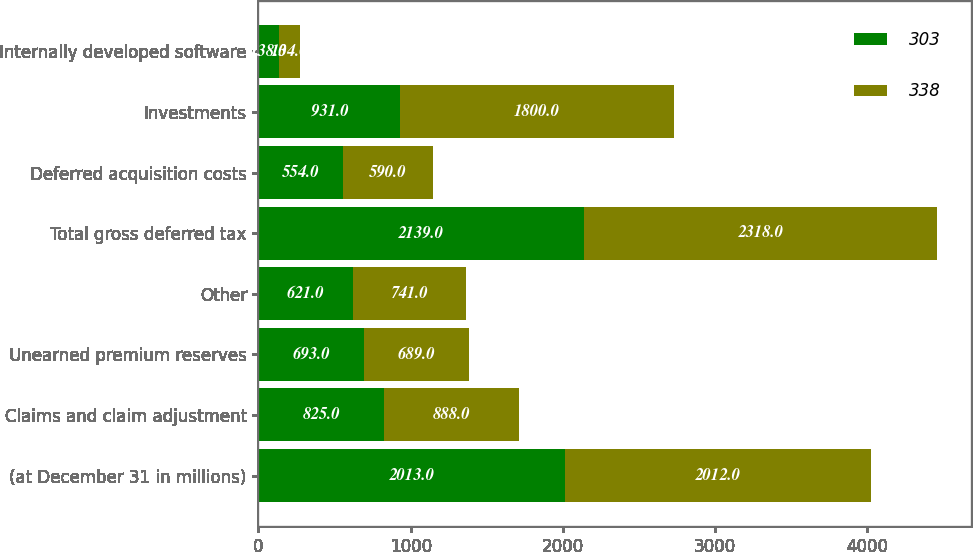Convert chart to OTSL. <chart><loc_0><loc_0><loc_500><loc_500><stacked_bar_chart><ecel><fcel>(at December 31 in millions)<fcel>Claims and claim adjustment<fcel>Unearned premium reserves<fcel>Other<fcel>Total gross deferred tax<fcel>Deferred acquisition costs<fcel>Investments<fcel>Internally developed software<nl><fcel>303<fcel>2013<fcel>825<fcel>693<fcel>621<fcel>2139<fcel>554<fcel>931<fcel>138<nl><fcel>338<fcel>2012<fcel>888<fcel>689<fcel>741<fcel>2318<fcel>590<fcel>1800<fcel>134<nl></chart> 